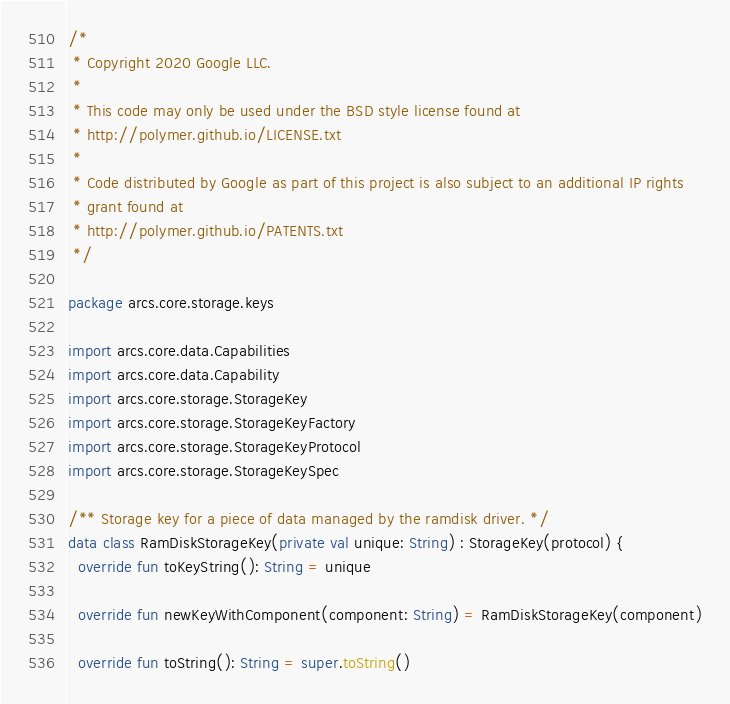Convert code to text. <code><loc_0><loc_0><loc_500><loc_500><_Kotlin_>/*
 * Copyright 2020 Google LLC.
 *
 * This code may only be used under the BSD style license found at
 * http://polymer.github.io/LICENSE.txt
 *
 * Code distributed by Google as part of this project is also subject to an additional IP rights
 * grant found at
 * http://polymer.github.io/PATENTS.txt
 */

package arcs.core.storage.keys

import arcs.core.data.Capabilities
import arcs.core.data.Capability
import arcs.core.storage.StorageKey
import arcs.core.storage.StorageKeyFactory
import arcs.core.storage.StorageKeyProtocol
import arcs.core.storage.StorageKeySpec

/** Storage key for a piece of data managed by the ramdisk driver. */
data class RamDiskStorageKey(private val unique: String) : StorageKey(protocol) {
  override fun toKeyString(): String = unique

  override fun newKeyWithComponent(component: String) = RamDiskStorageKey(component)

  override fun toString(): String = super.toString()
</code> 